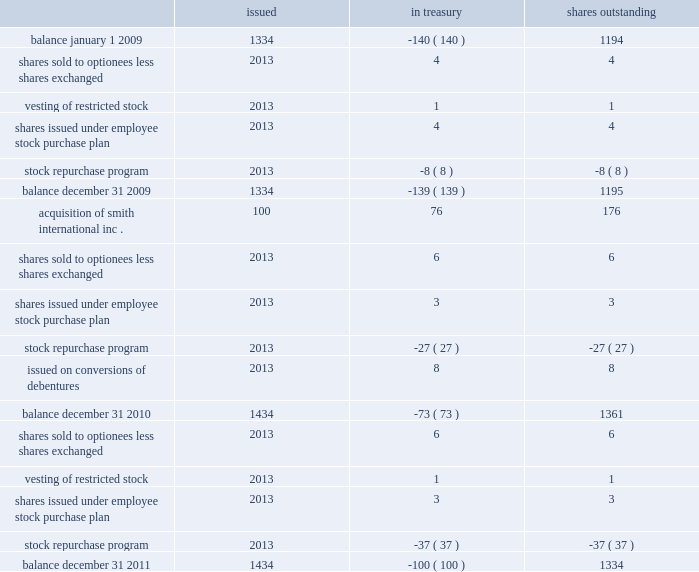Schlumberger limited and subsidiaries shares of common stock ( stated in millions ) issued in treasury shares outstanding .
See the notes to consolidated financial statements .
What was the total of shares ( millions ) issued to employees in the 3 year period? 
Computations: (((((4 + 4) + 6) + 3) + 6) + 3)
Answer: 26.0. Schlumberger limited and subsidiaries shares of common stock ( stated in millions ) issued in treasury shares outstanding .
See the notes to consolidated financial statements .
What was the net change in shares outstanding during 2011? 
Computations: (1434 - 1434)
Answer: 0.0. 